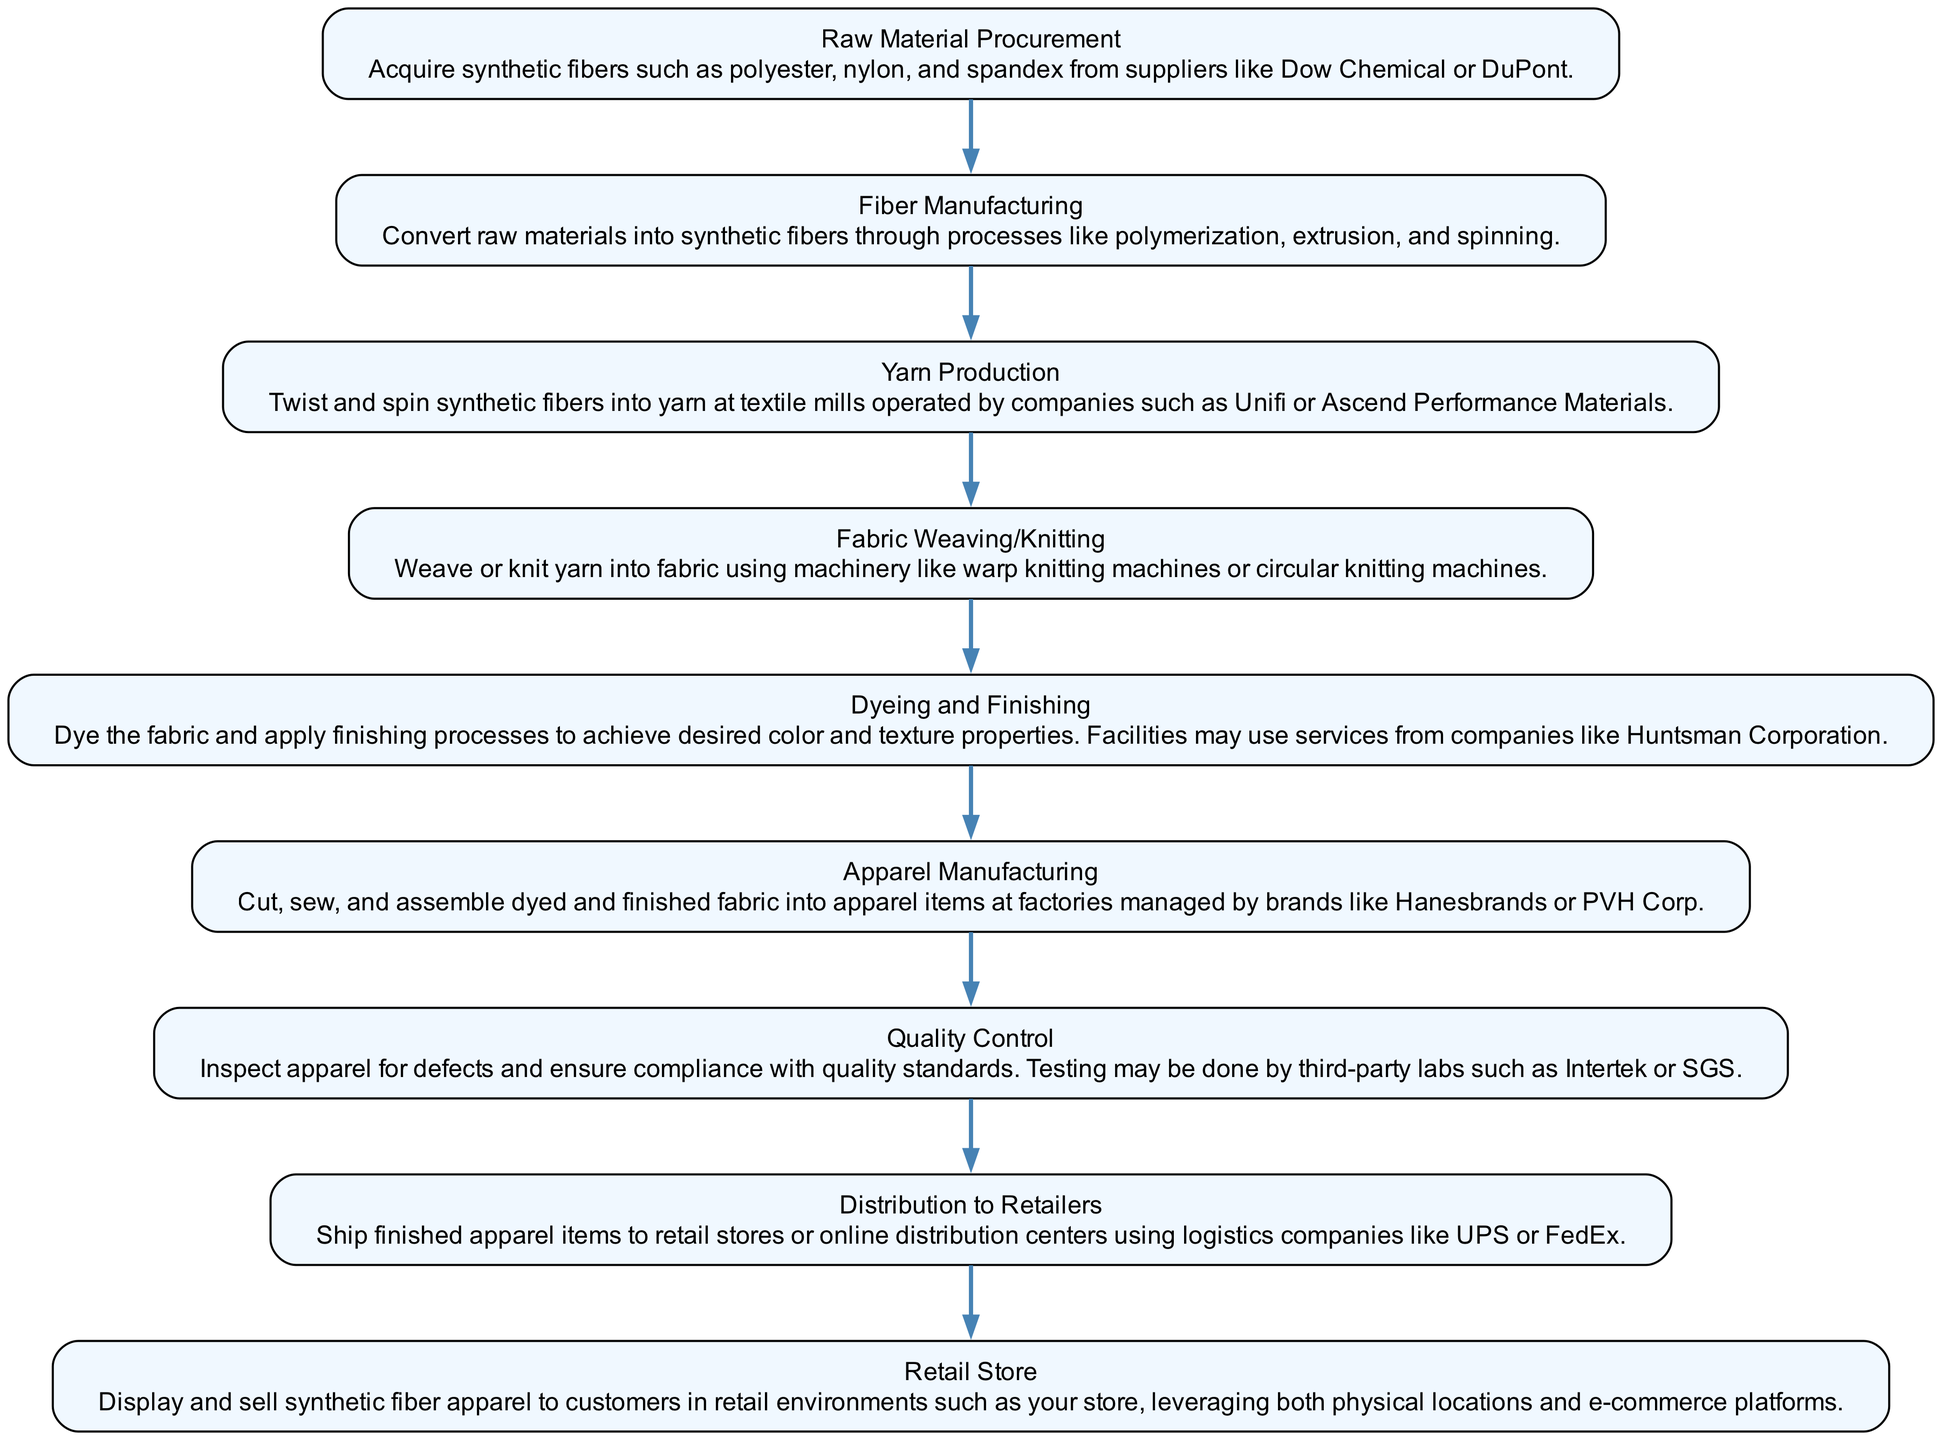What is the first step in the supply chain process? The first step in the supply chain process is "Raw Material Procurement," which involves acquiring synthetic fibers from suppliers.
Answer: Raw Material Procurement How many steps are there in total in the process? Counting each distinct step in the supply chain, there are nine steps from "Raw Material Procurement" to "Retail Store."
Answer: Nine Which company is mentioned as a supplier for Raw Material Procurement? The diagram indicates that suppliers for synthetic fibers include companies like Dow Chemical or DuPont.
Answer: Dow Chemical or DuPont What follows after Yarn Production in the sequence? After Yarn Production, the next step is "Fabric Weaving/Knitting," where the yarn is woven or knitted into fabric.
Answer: Fabric Weaving/Knitting Which step includes dyeing the fabric? The step that includes dyeing the fabric is "Dyeing and Finishing," where the fabric is dyed and finishing processes are applied.
Answer: Dyeing and Finishing What is the last step before products reach the "Retail Store"? The last step before reaching the Retail Store is "Distribution to Retailers," where finished apparel items are shipped to retail locations or online centers.
Answer: Distribution to Retailers Which step involves inspecting apparel for defects? "Quality Control" is the step that focuses on inspecting apparel for defects and ensuring compliance with quality standards.
Answer: Quality Control What is the relationship between Fabric Weaving/Knitting and Apparel Manufacturing? Fabric Weaving/Knitting leads directly to Apparel Manufacturing, indicating that once fabric is created, it is then cut, sewn, and assembled into apparel.
Answer: Fabric Weaving/Knitting leads to Apparel Manufacturing How many companies are mentioned in the supply chain processing steps? The diagram mentions several companies involved in various steps, including Dow Chemical, DuPont, Unifi, Ascend Performance Materials, Huntsman Corporation, Hanesbrands, PVH Corp, Intertek, and SGS, totaling eight companies.
Answer: Eight companies 